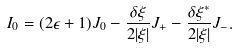Convert formula to latex. <formula><loc_0><loc_0><loc_500><loc_500>I _ { 0 } = ( 2 \epsilon + 1 ) J _ { 0 } - \frac { \delta \xi } { 2 | \xi | } J _ { + } - \frac { \delta \xi ^ { * } } { 2 | \xi | } J _ { - } .</formula> 